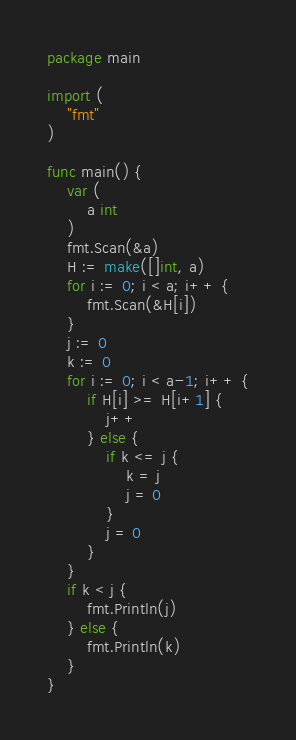Convert code to text. <code><loc_0><loc_0><loc_500><loc_500><_Go_>package main

import (
	"fmt"
)

func main() {
	var (
		a int
	)
	fmt.Scan(&a)
	H := make([]int, a)
	for i := 0; i < a; i++ {
		fmt.Scan(&H[i])
	}
	j := 0
	k := 0
	for i := 0; i < a-1; i++ {
		if H[i] >= H[i+1] {
			j++
		} else {
			if k <= j {
				k = j
				j = 0
			}
			j = 0
		}
	}
	if k < j {
		fmt.Println(j)
	} else {
		fmt.Println(k)
	}
}
</code> 